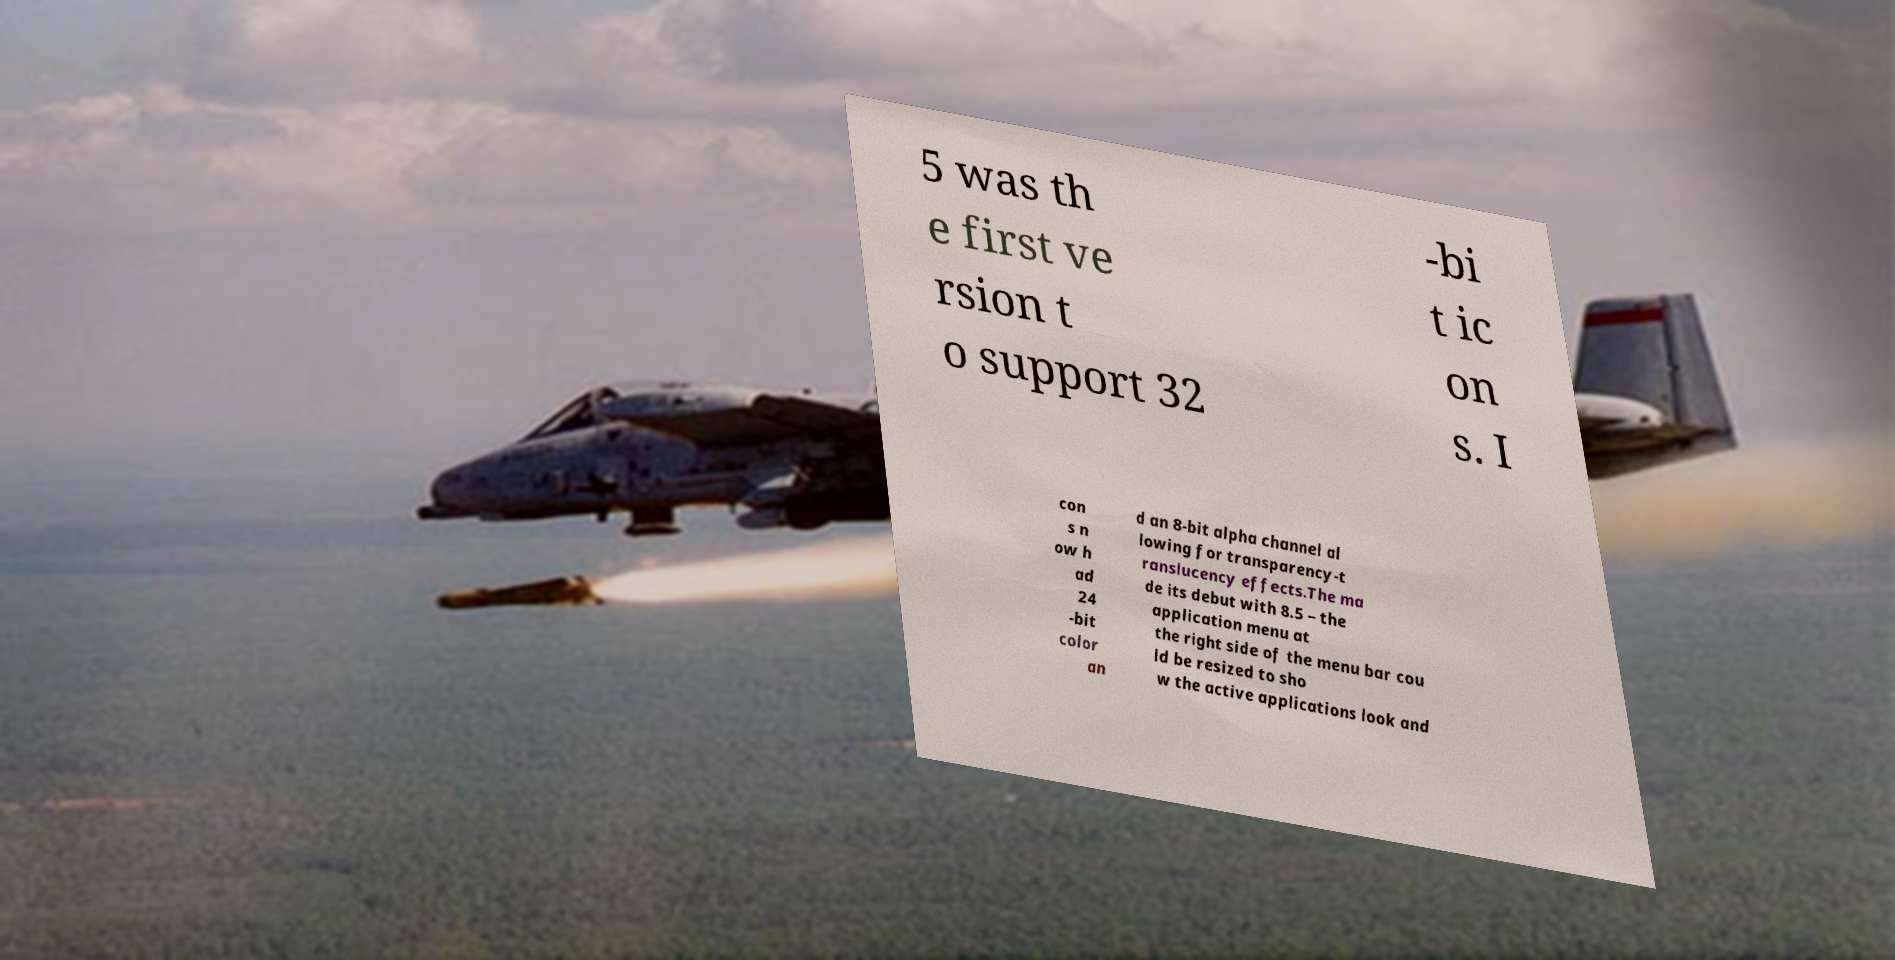Can you accurately transcribe the text from the provided image for me? 5 was th e first ve rsion t o support 32 -bi t ic on s. I con s n ow h ad 24 -bit color an d an 8-bit alpha channel al lowing for transparency-t ranslucency effects.The ma de its debut with 8.5 – the application menu at the right side of the menu bar cou ld be resized to sho w the active applications look and 